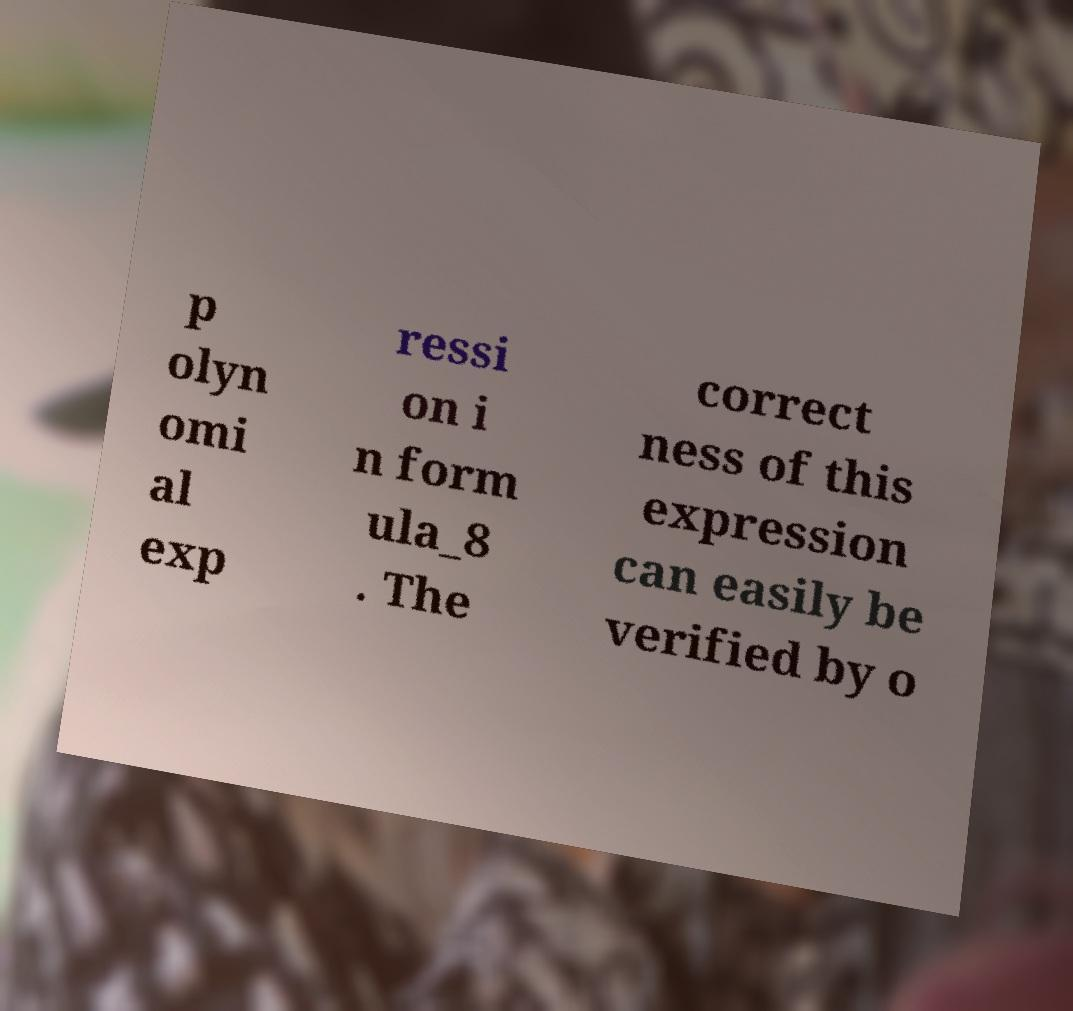I need the written content from this picture converted into text. Can you do that? p olyn omi al exp ressi on i n form ula_8 . The correct ness of this expression can easily be verified by o 